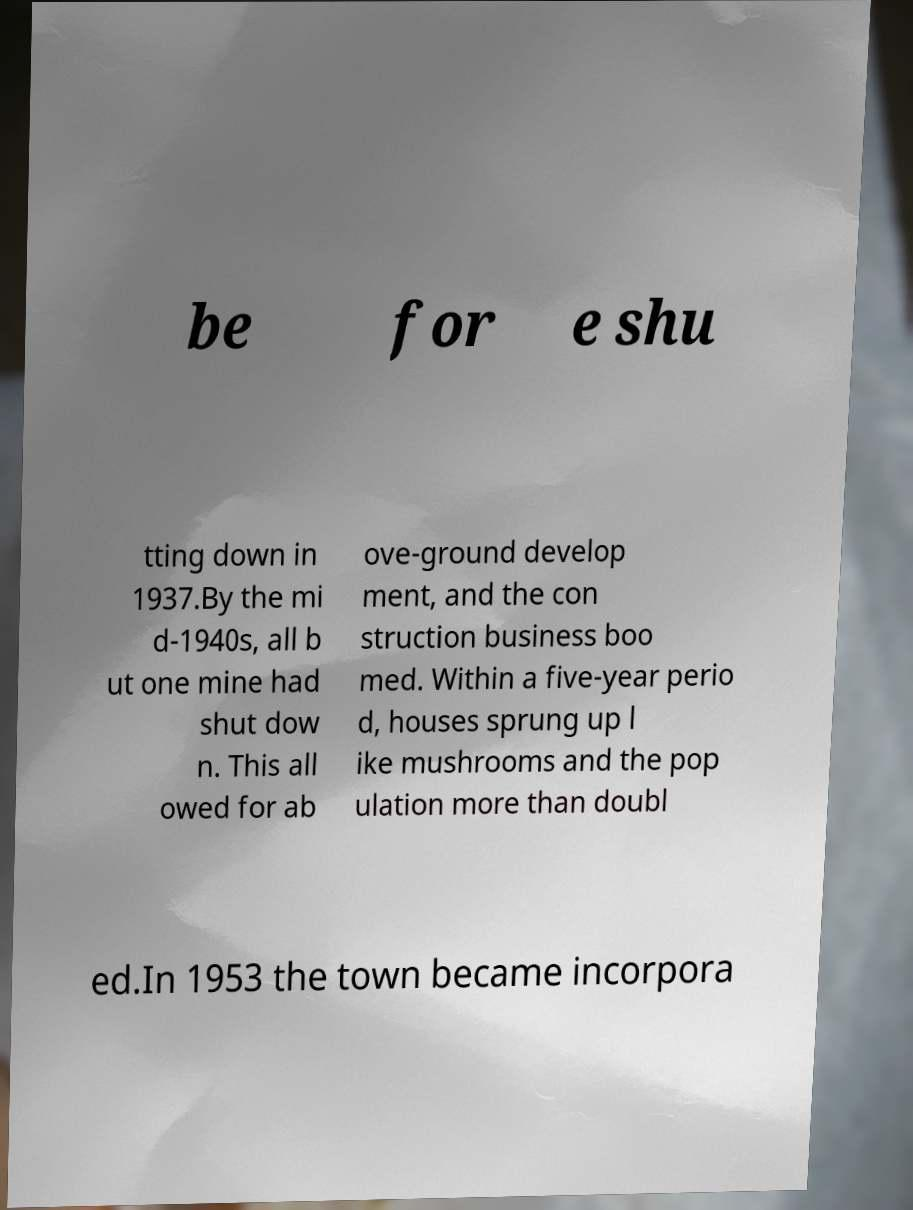Can you accurately transcribe the text from the provided image for me? be for e shu tting down in 1937.By the mi d-1940s, all b ut one mine had shut dow n. This all owed for ab ove-ground develop ment, and the con struction business boo med. Within a five-year perio d, houses sprung up l ike mushrooms and the pop ulation more than doubl ed.In 1953 the town became incorpora 